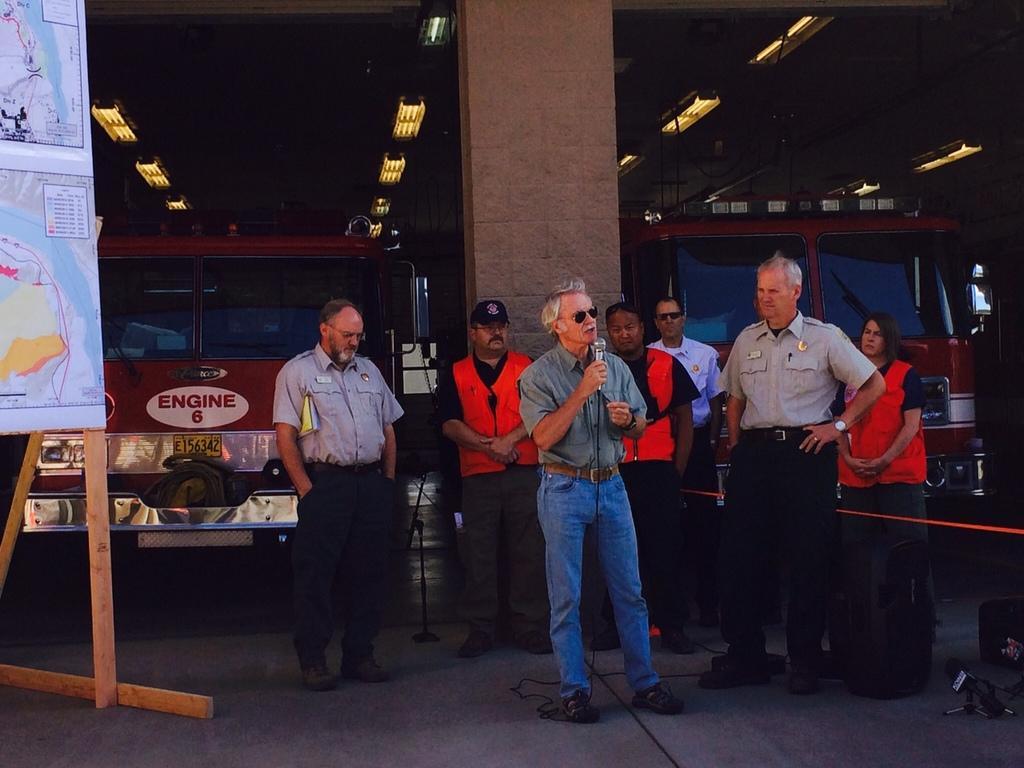How would you summarize this image in a sentence or two? In this image there is a person holding a mike. There are people standing on the floor. Left side there is a board attached to the stand. There are objects on the floor. Top of the image there are lights attached to the roof. 